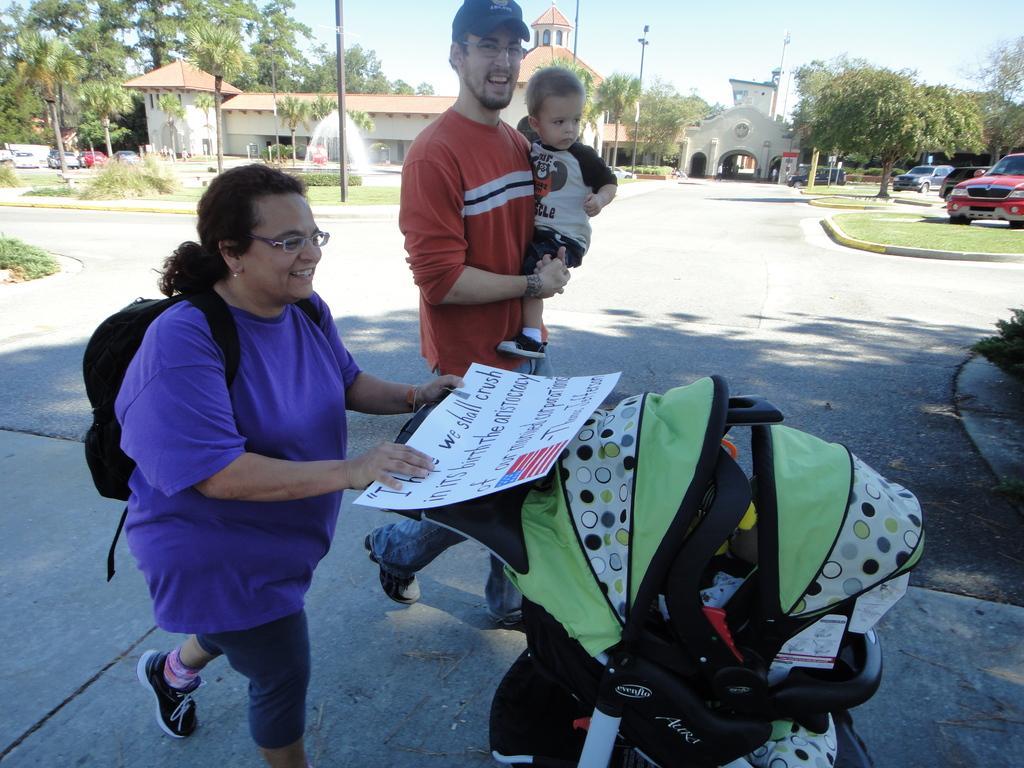In one or two sentences, can you explain what this image depicts? In the left side a woman is walking, she wore a blue color t-shirt. In the middle a man is walking by holding a baby, he wore an orange color t-shirt. This is the road, in the right side few vehicles are parked on this road, in the left side there are trees. 